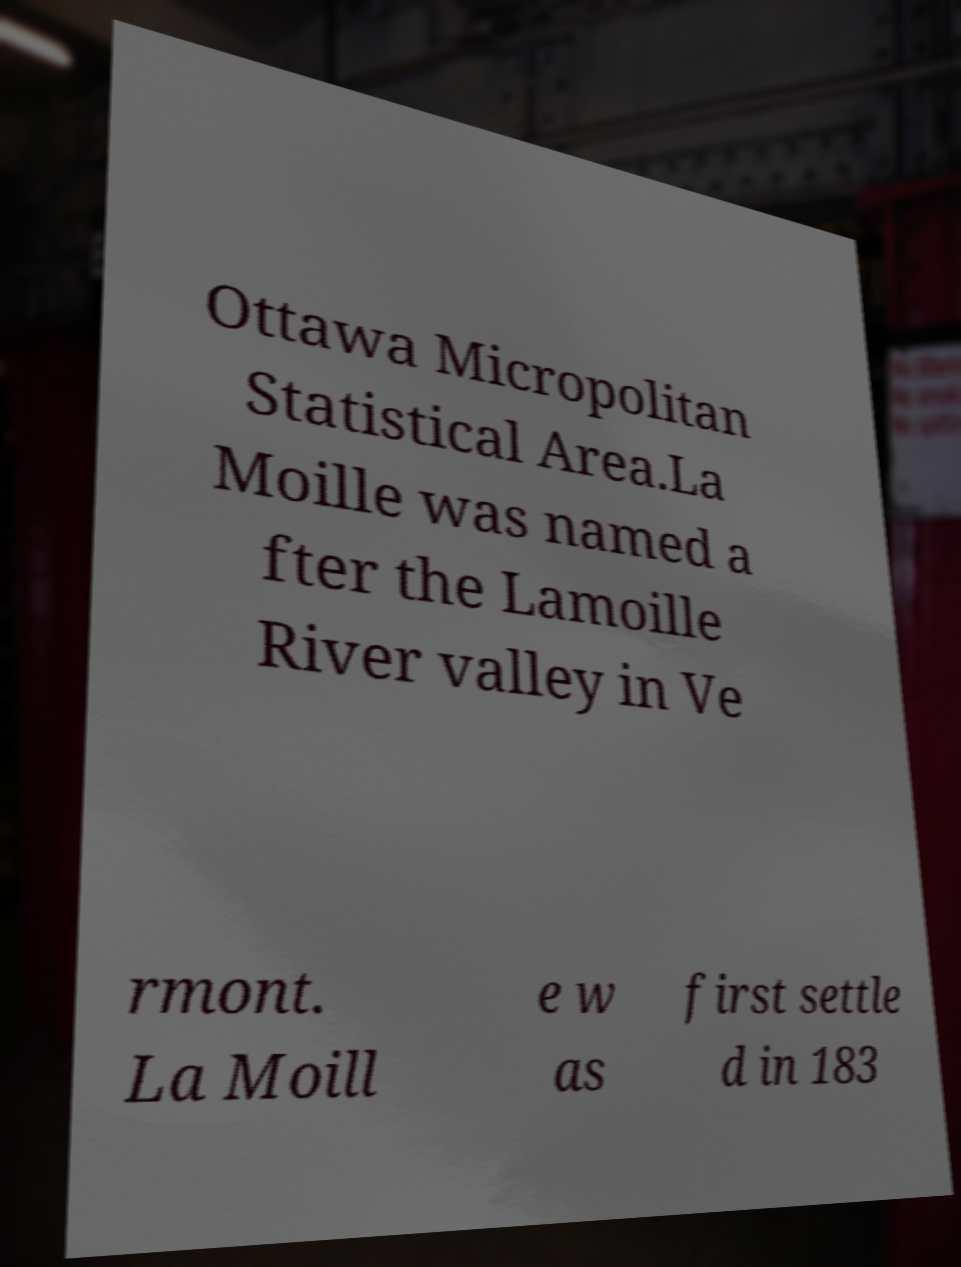For documentation purposes, I need the text within this image transcribed. Could you provide that? Ottawa Micropolitan Statistical Area.La Moille was named a fter the Lamoille River valley in Ve rmont. La Moill e w as first settle d in 183 